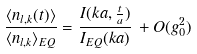<formula> <loc_0><loc_0><loc_500><loc_500>\frac { \langle n _ { l , k } ( t ) \rangle } { \langle n _ { l , k } \rangle _ { E Q } } = \frac { I ( k a , \frac { t } { a } ) } { I _ { E Q } ( k a ) } \, + O ( g _ { 0 } ^ { 2 } )</formula> 